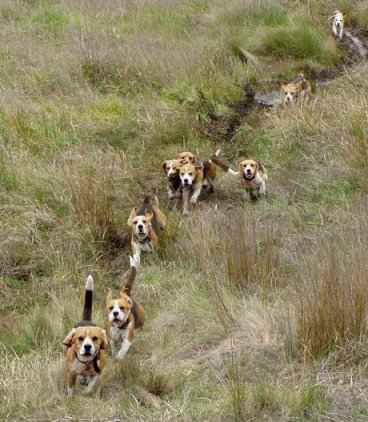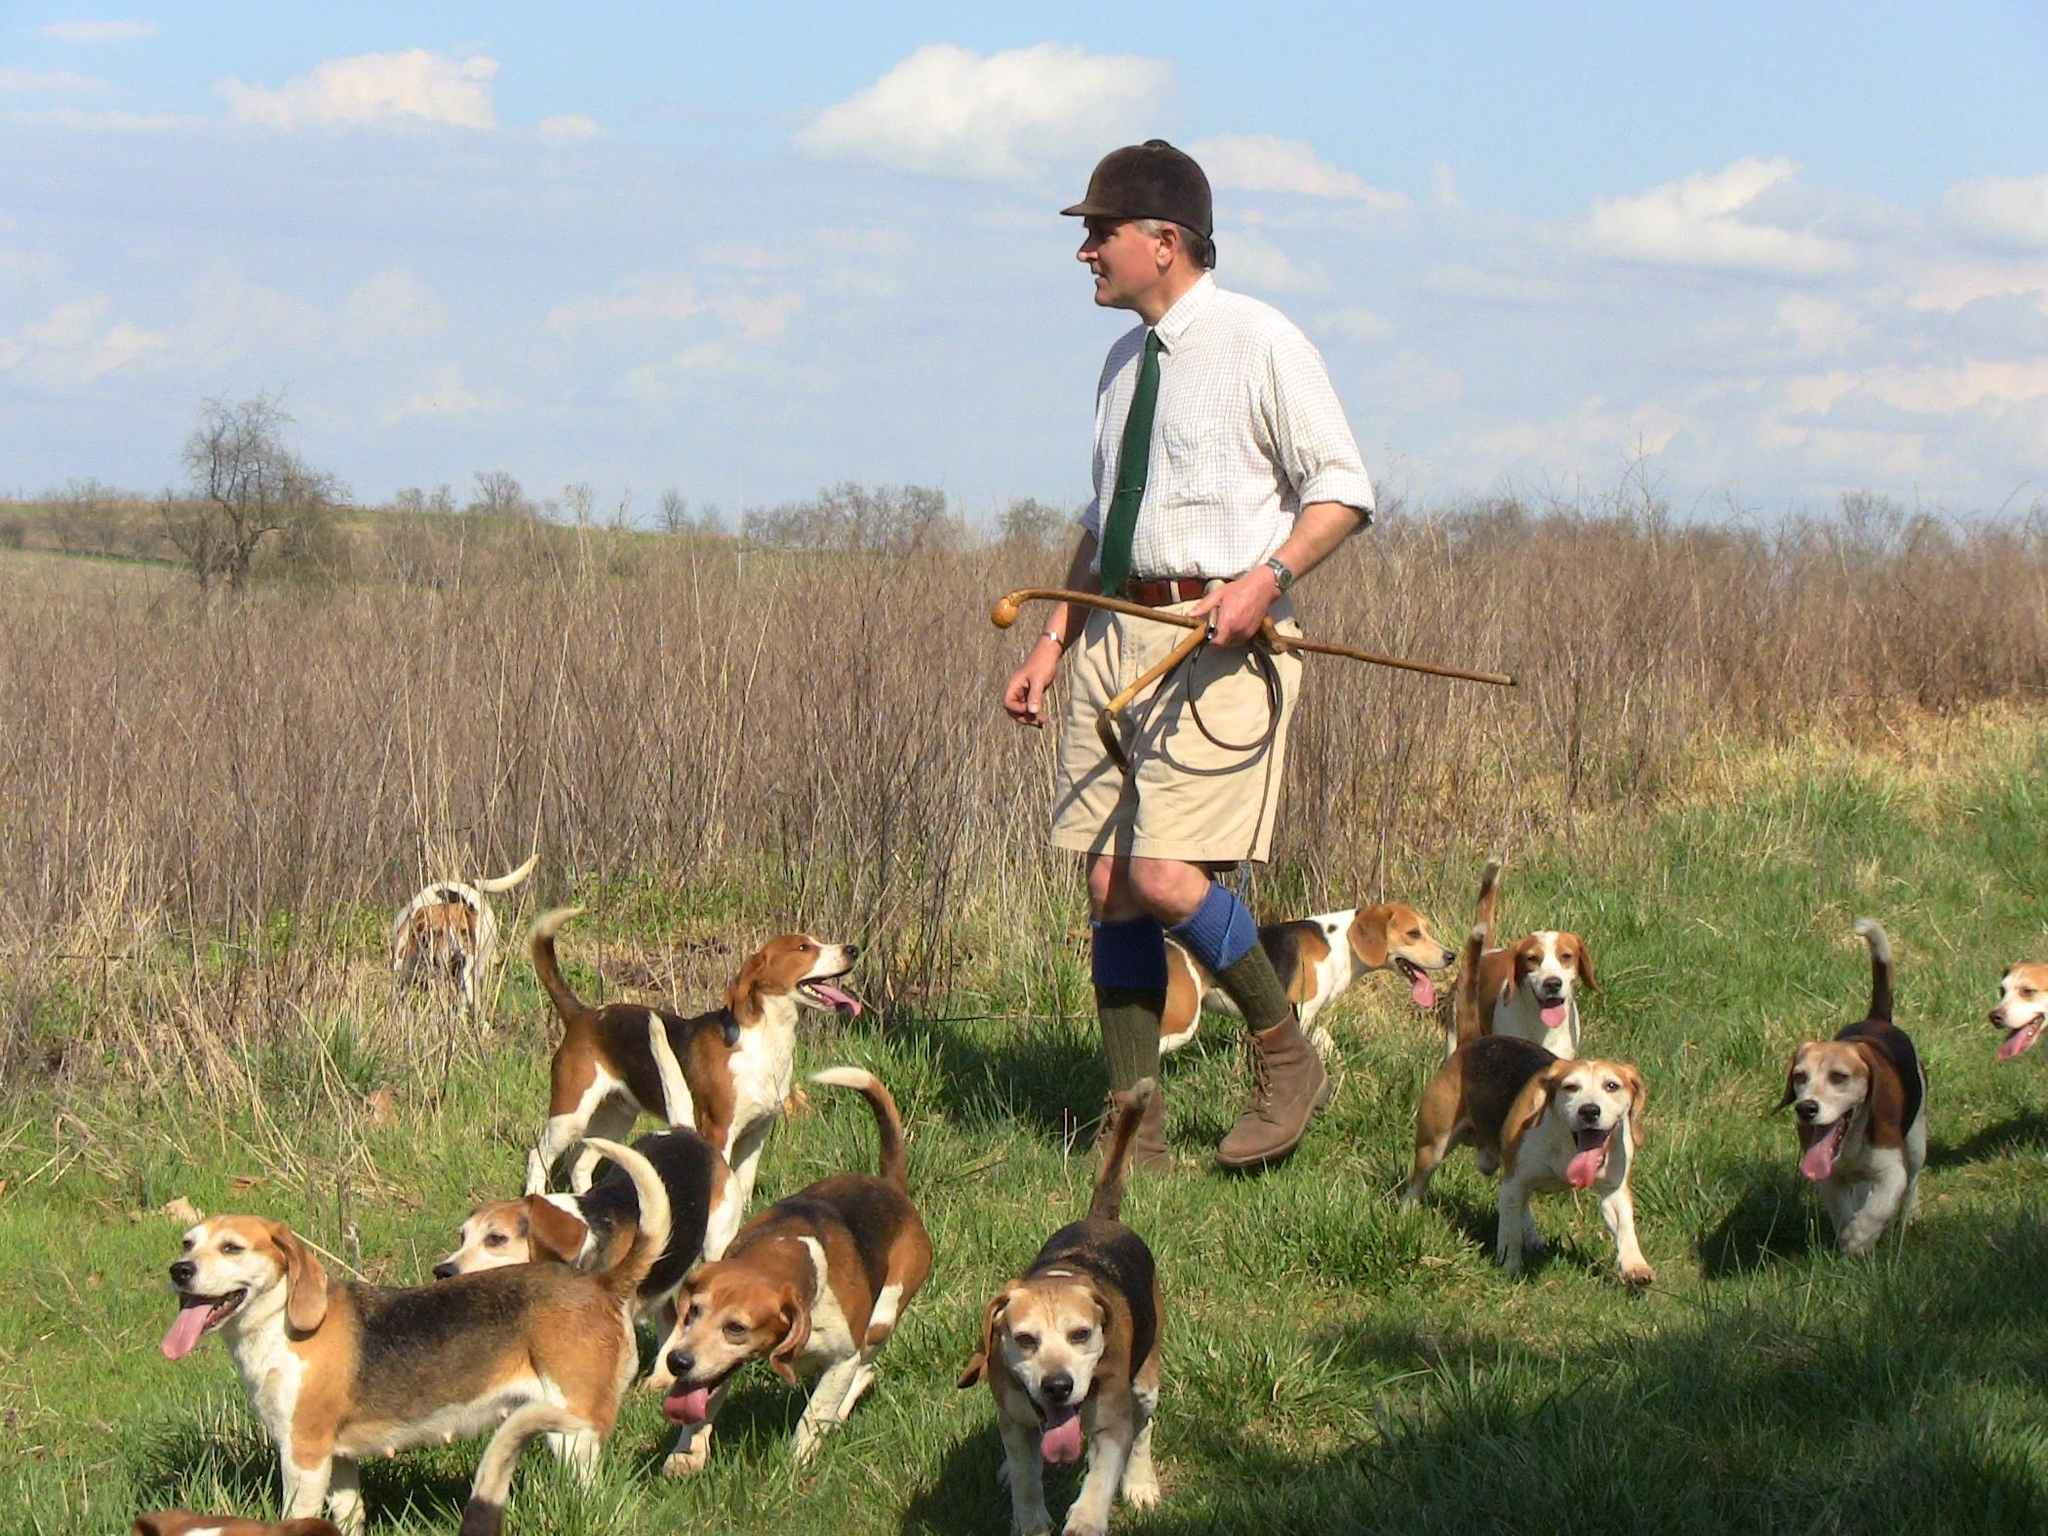The first image is the image on the left, the second image is the image on the right. Analyze the images presented: Is the assertion "There are no more than three animals in the image on the right" valid? Answer yes or no. No. 